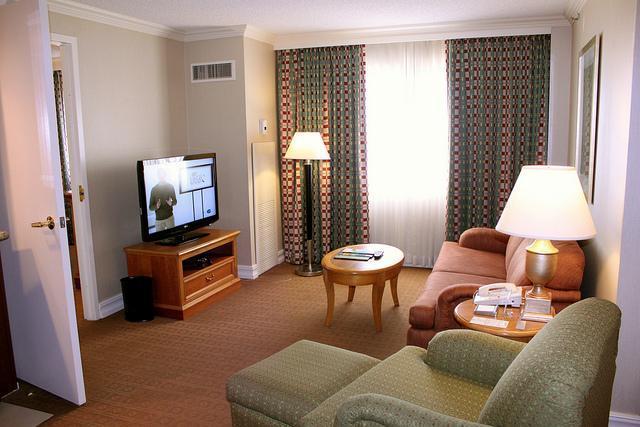How many couches are in the photo?
Give a very brief answer. 2. 